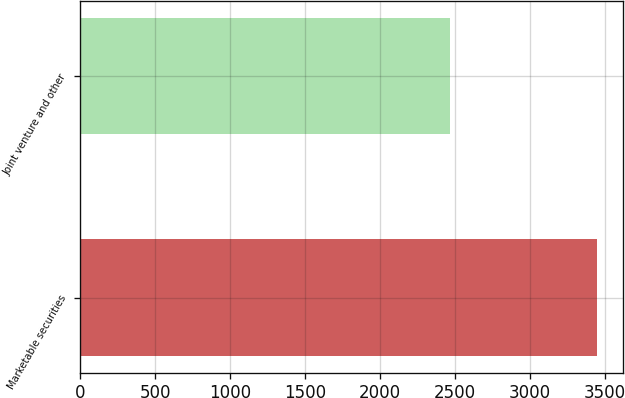Convert chart to OTSL. <chart><loc_0><loc_0><loc_500><loc_500><bar_chart><fcel>Marketable securities<fcel>Joint venture and other<nl><fcel>3451<fcel>2468<nl></chart> 